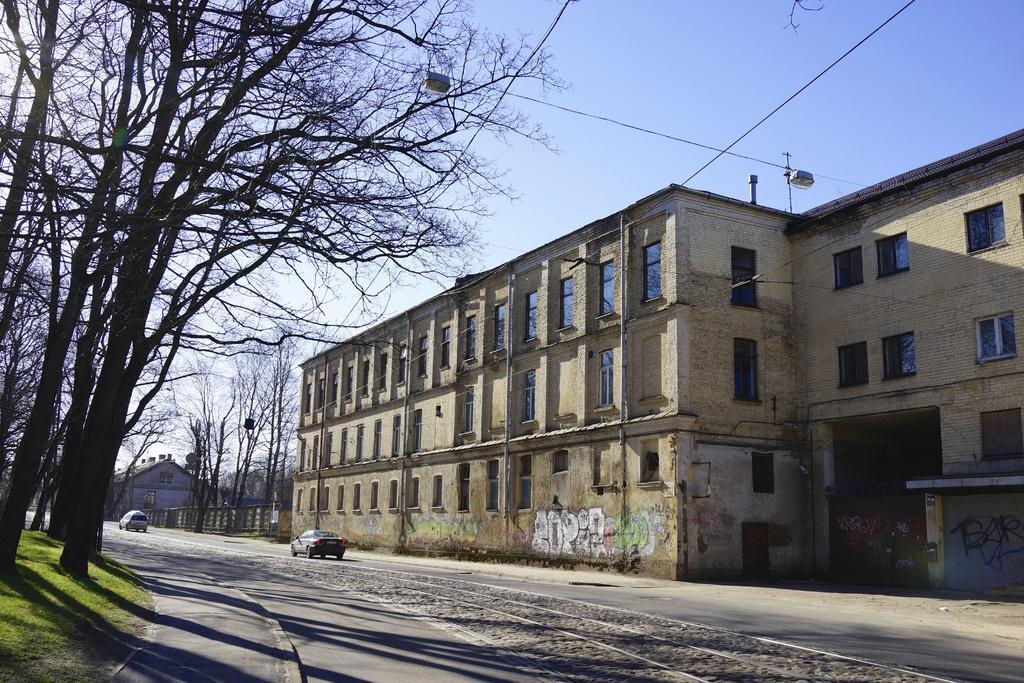How would you summarize this image in a sentence or two? In this image, there is an outside view. There are some trees on the left side of the image. There is a building in the middle of the image. There are cars in the bottom left of the image. There is a sky at the top of the image. 